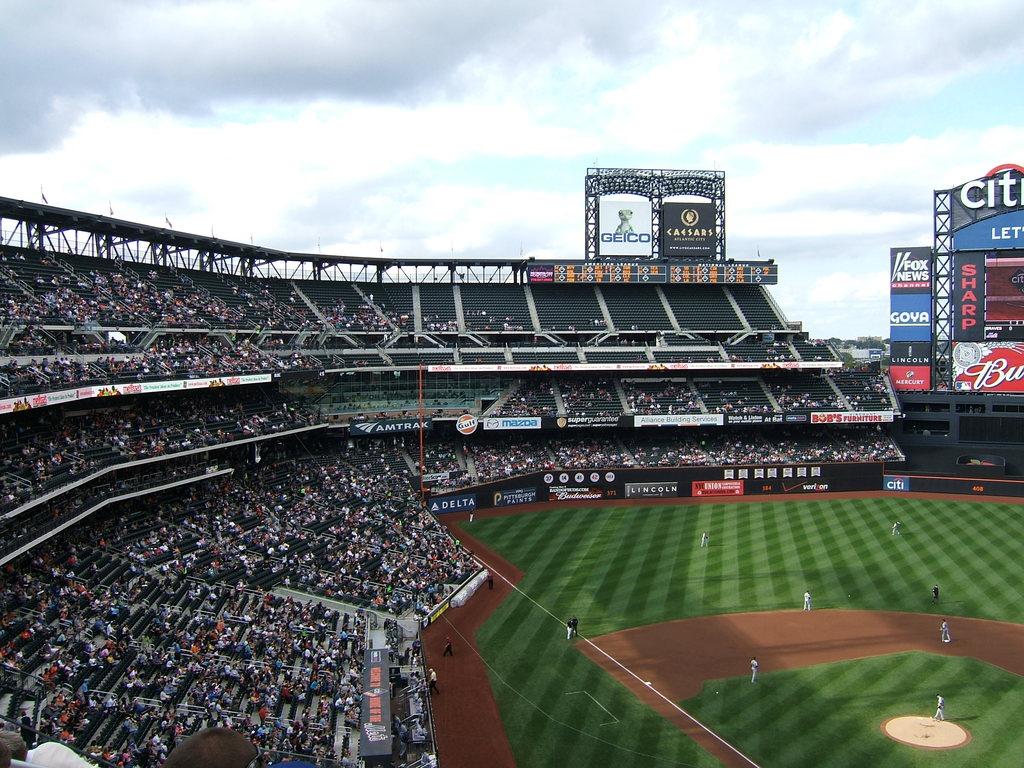What is one of the large brands advertised here?
Make the answer very short. Budweiser. What insurance company is a sponsor?
Provide a short and direct response. Geico. 